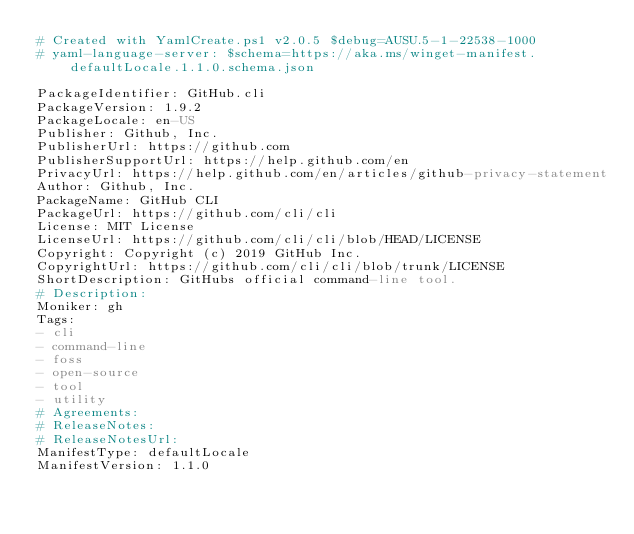Convert code to text. <code><loc_0><loc_0><loc_500><loc_500><_YAML_># Created with YamlCreate.ps1 v2.0.5 $debug=AUSU.5-1-22538-1000
# yaml-language-server: $schema=https://aka.ms/winget-manifest.defaultLocale.1.1.0.schema.json

PackageIdentifier: GitHub.cli
PackageVersion: 1.9.2
PackageLocale: en-US
Publisher: Github, Inc.
PublisherUrl: https://github.com
PublisherSupportUrl: https://help.github.com/en
PrivacyUrl: https://help.github.com/en/articles/github-privacy-statement
Author: Github, Inc.
PackageName: GitHub CLI
PackageUrl: https://github.com/cli/cli
License: MIT License
LicenseUrl: https://github.com/cli/cli/blob/HEAD/LICENSE
Copyright: Copyright (c) 2019 GitHub Inc.
CopyrightUrl: https://github.com/cli/cli/blob/trunk/LICENSE
ShortDescription: GitHubs official command-line tool.
# Description: 
Moniker: gh
Tags:
- cli
- command-line
- foss
- open-source
- tool
- utility
# Agreements: 
# ReleaseNotes: 
# ReleaseNotesUrl: 
ManifestType: defaultLocale
ManifestVersion: 1.1.0
</code> 